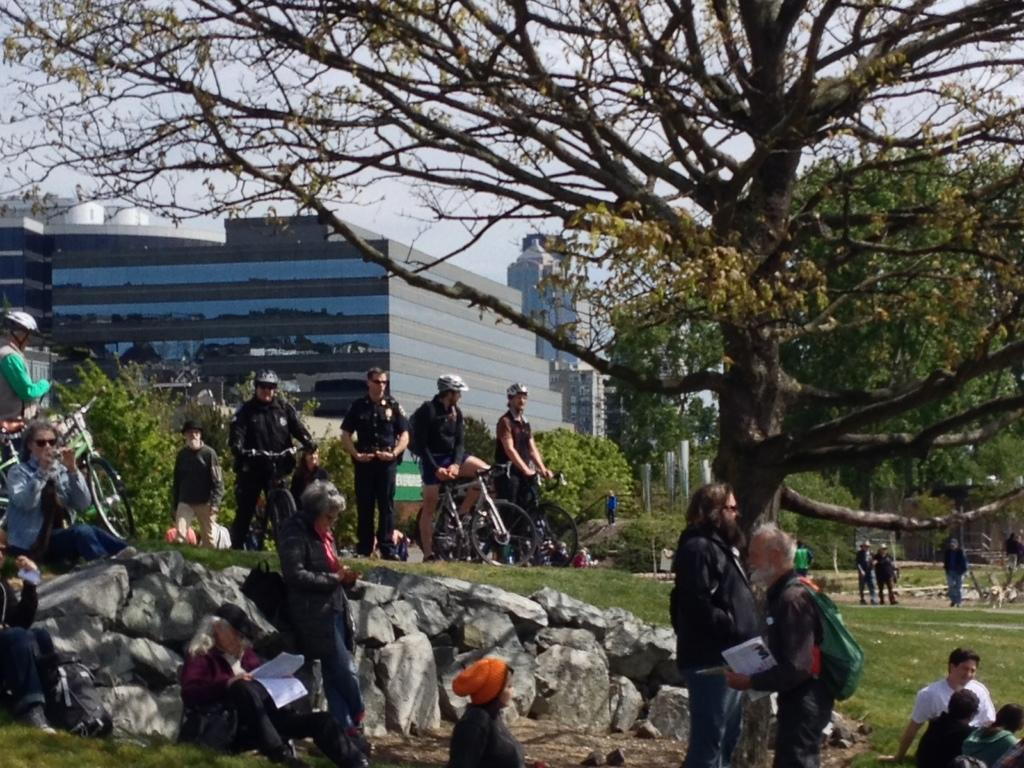What are the people in the image doing? The people in the image are standing and sitting on the surface of the grass. What can be seen in the background of the image? There are trees and buildings in the background of the image. What type of clock can be seen hanging from the tree in the image? There is no clock present in the image, and no clock is hanging from the tree. 